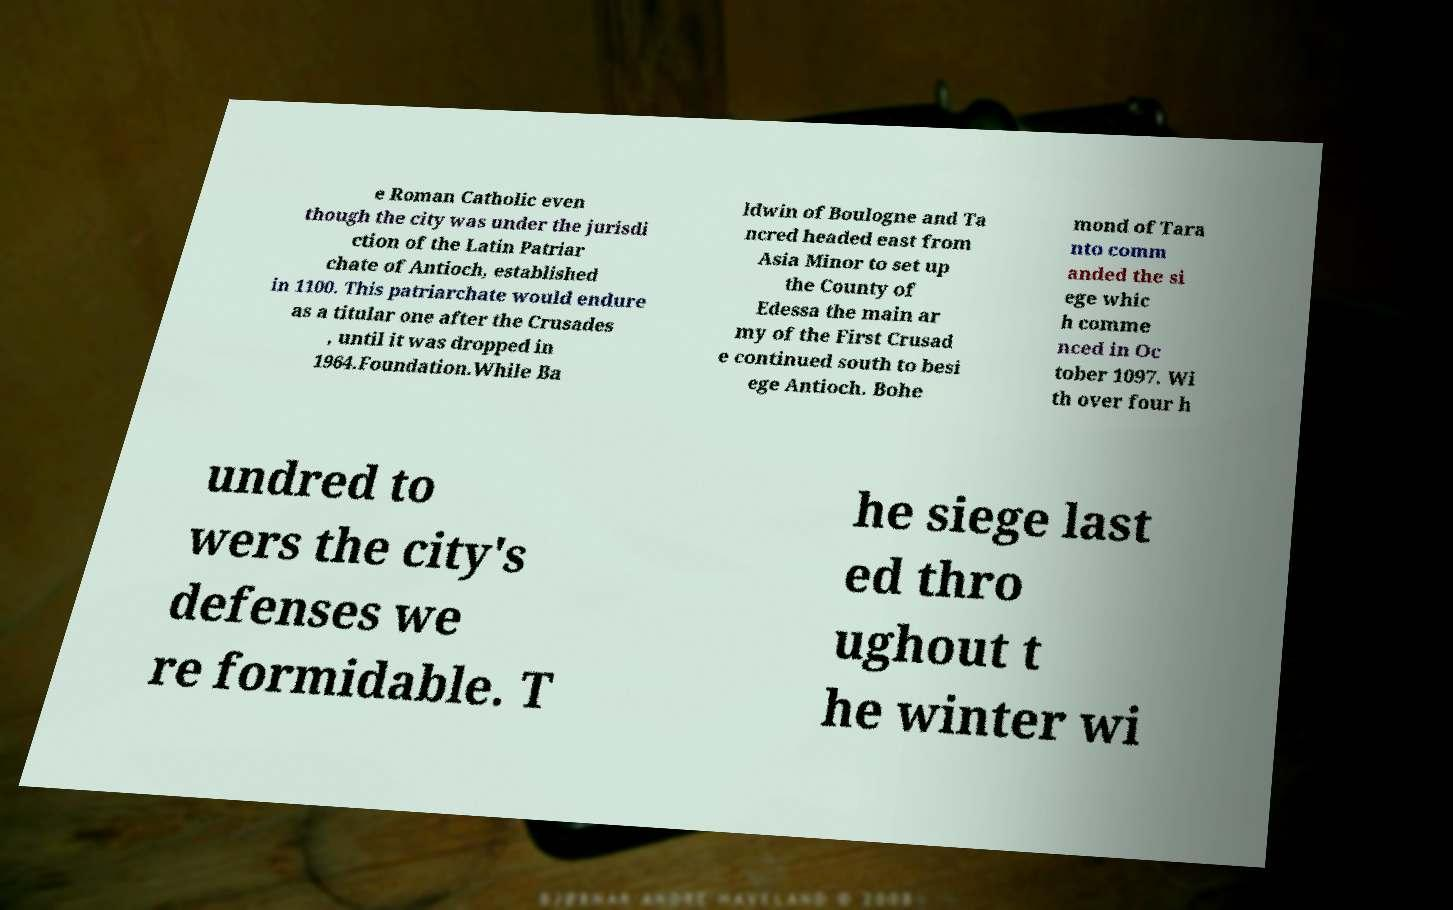Please read and relay the text visible in this image. What does it say? e Roman Catholic even though the city was under the jurisdi ction of the Latin Patriar chate of Antioch, established in 1100. This patriarchate would endure as a titular one after the Crusades , until it was dropped in 1964.Foundation.While Ba ldwin of Boulogne and Ta ncred headed east from Asia Minor to set up the County of Edessa the main ar my of the First Crusad e continued south to besi ege Antioch. Bohe mond of Tara nto comm anded the si ege whic h comme nced in Oc tober 1097. Wi th over four h undred to wers the city's defenses we re formidable. T he siege last ed thro ughout t he winter wi 